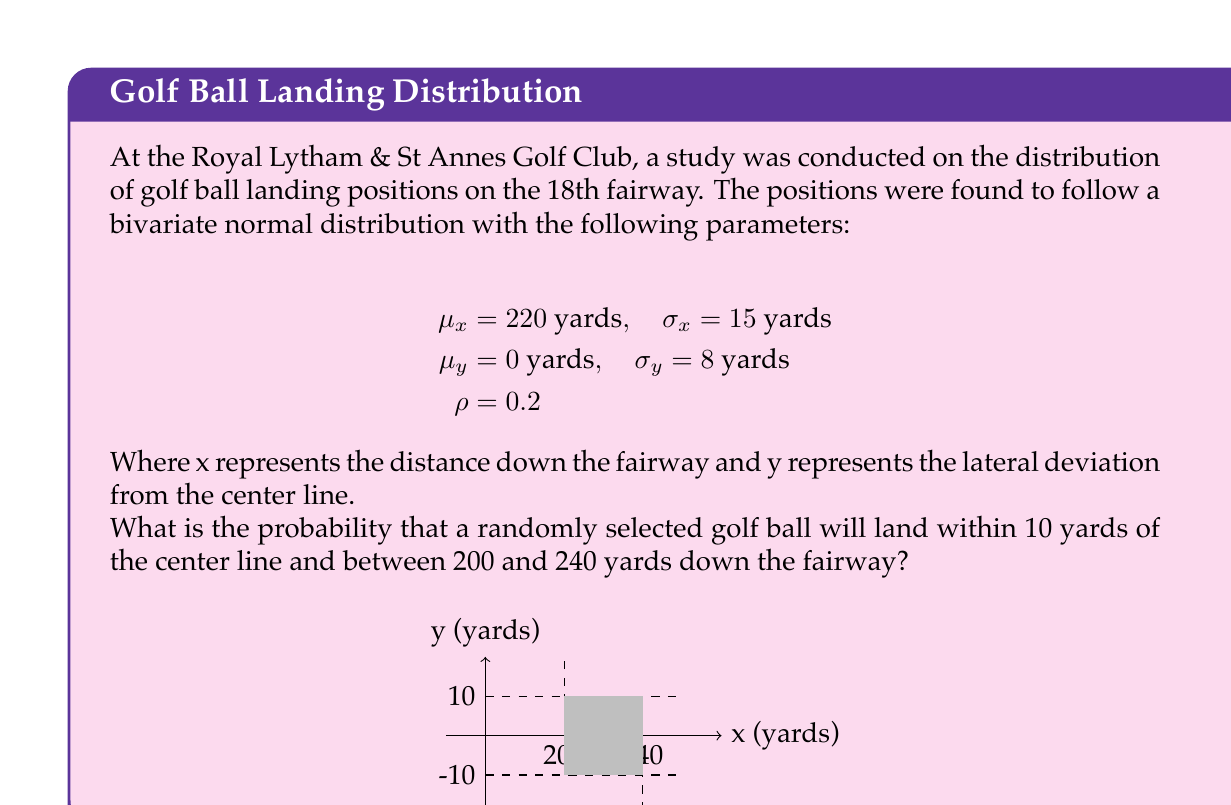Provide a solution to this math problem. To solve this problem, we need to use the properties of the bivariate normal distribution and integrate over the specified region. Let's break it down step-by-step:

1) First, we need to standardize the variables. For a bivariate normal distribution, we use the formula:

   $$Z_x = \frac{x - \mu_x}{\sigma_x}, Z_y = \frac{y - \mu_y}{\sigma_y}$$

2) For the x-axis (distance down the fairway):
   $$Z_{x1} = \frac{200 - 220}{15} = -\frac{4}{3}, Z_{x2} = \frac{240 - 220}{15} = \frac{4}{3}$$

3) For the y-axis (lateral deviation):
   $$Z_{y1} = \frac{-10 - 0}{8} = -\frac{5}{4}, Z_{y2} = \frac{10 - 0}{8} = \frac{5}{4}$$

4) The probability density function for a bivariate normal distribution is:

   $$f(x,y) = \frac{1}{2\pi\sigma_x\sigma_y\sqrt{1-\rho^2}} \exp\left(-\frac{1}{2(1-\rho^2)}[(\frac{x-\mu_x}{\sigma_x})^2 - 2\rho(\frac{x-\mu_x}{\sigma_x})(\frac{y-\mu_y}{\sigma_y}) + (\frac{y-\mu_y}{\sigma_y})^2]\right)$$

5) To find the probability, we need to integrate this function over the specified region:

   $$P = \int_{-10}^{10} \int_{200}^{240} f(x,y) dx dy$$

6) This integral is complex and typically requires numerical methods to solve. We can use statistical software or numerical integration techniques to evaluate it.

7) Using a statistical software package, we can calculate that the probability is approximately 0.3894 or 38.94%.
Answer: 0.3894 (or 38.94%) 